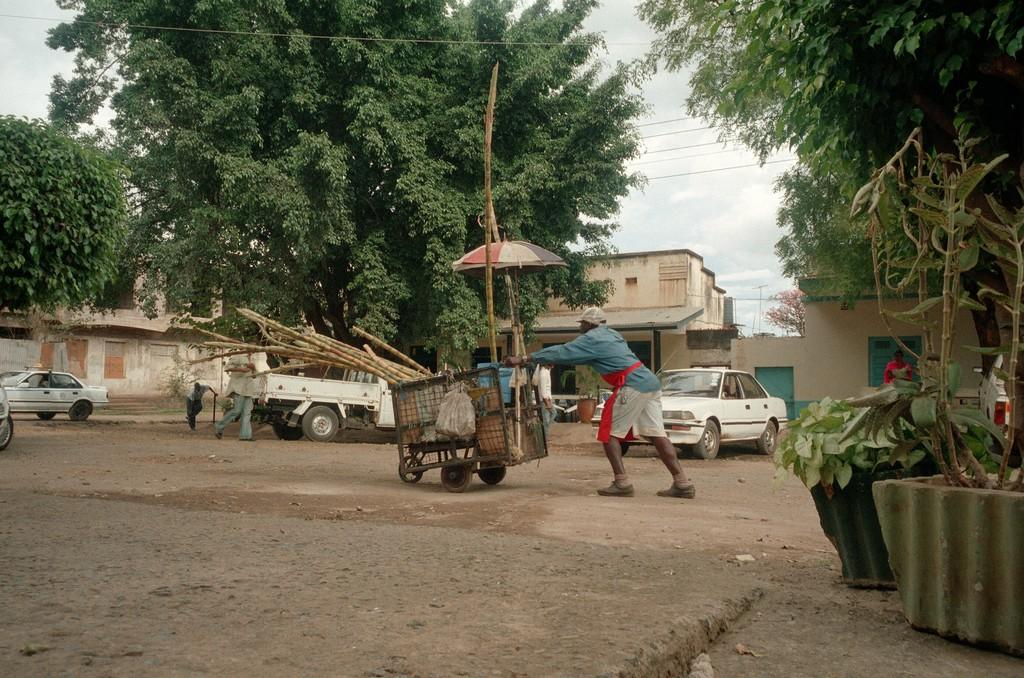What is the person in the image doing with a vehicle? The person is moving with a vehicle in the image. Are there any other vehicles visible in the image? Yes, there are other cars in the image. What type of structures can be seen in the image? There are buildings in the image. What type of vegetation is present in the image? There are trees in the image. What type of containers for plants can be seen in the image? There are plant pots in the image. What type of sack is being used to lift the vehicle in the image? There is no sack being used to lift the vehicle in the image; the person is simply moving with the vehicle. 